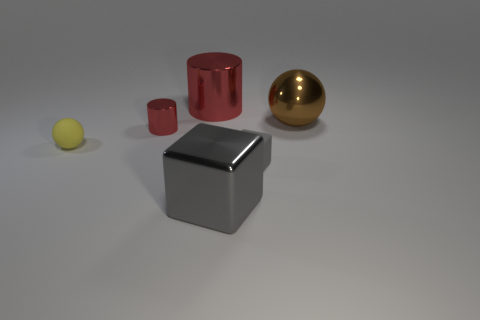Subtract all red cylinders. How many were subtracted if there are1red cylinders left? 1 Add 2 tiny gray matte objects. How many objects exist? 8 Subtract all blocks. How many objects are left? 4 Subtract 0 cyan cylinders. How many objects are left? 6 Subtract all big red metallic objects. Subtract all tiny yellow matte things. How many objects are left? 4 Add 1 large brown things. How many large brown things are left? 2 Add 3 big brown balls. How many big brown balls exist? 4 